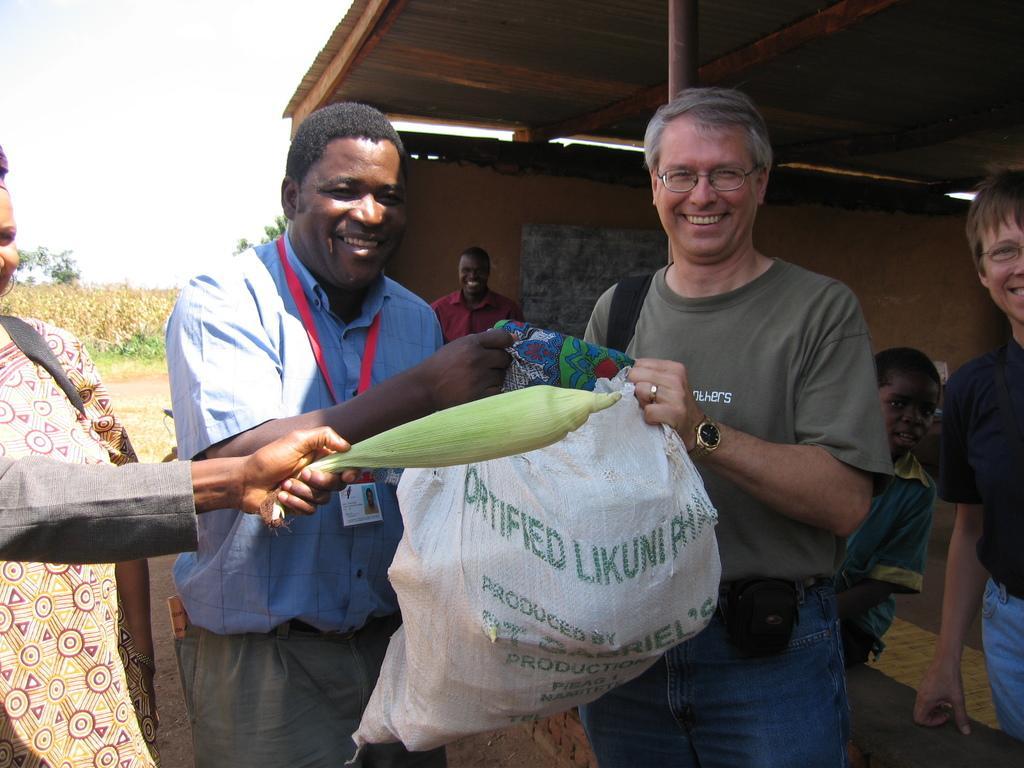Describe this image in one or two sentences. In this image I can see four persons standing, in front two persons holding a bag which is in white color, at right the person is wearing brown shirt, blue pant and at left the person is wearing blue shirt, gray pant. At back I can see few other person's, a wooden house, trees in green color, sky in white color. 